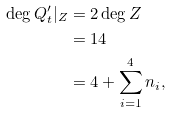<formula> <loc_0><loc_0><loc_500><loc_500>\deg Q ^ { \prime } _ { t } | _ { Z } & = 2 \deg Z \\ & = 1 4 \\ & = 4 + \sum _ { i = 1 } ^ { 4 } n _ { i } ,</formula> 